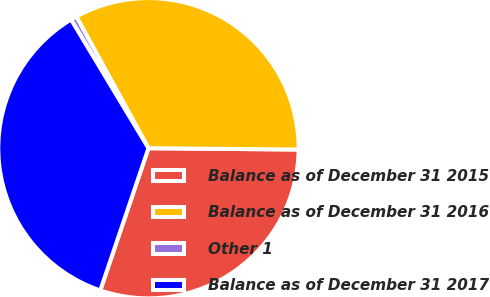Convert chart to OTSL. <chart><loc_0><loc_0><loc_500><loc_500><pie_chart><fcel>Balance as of December 31 2015<fcel>Balance as of December 31 2016<fcel>Other 1<fcel>Balance as of December 31 2017<nl><fcel>30.06%<fcel>33.12%<fcel>0.64%<fcel>36.18%<nl></chart> 